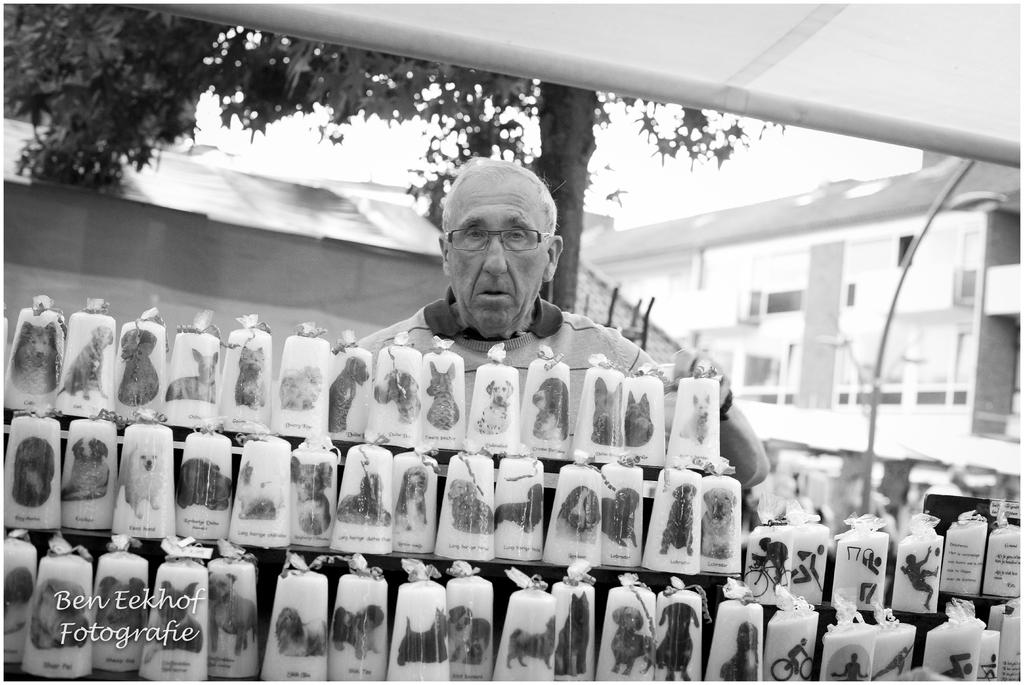What is the main subject of the image? There is a man standing in the image. What can be seen on the cart in the image? There are items on a cart in the image. What is visible in the background of the image? There are buildings and a tree visible in the image. Where is the text located in the image? The text is at the bottom left corner of the image. What type of holiday is being celebrated in the image? There is no indication of a holiday being celebrated in the image. What reward is the man receiving for his actions in the image? There is no reward being given to the man in the image. 